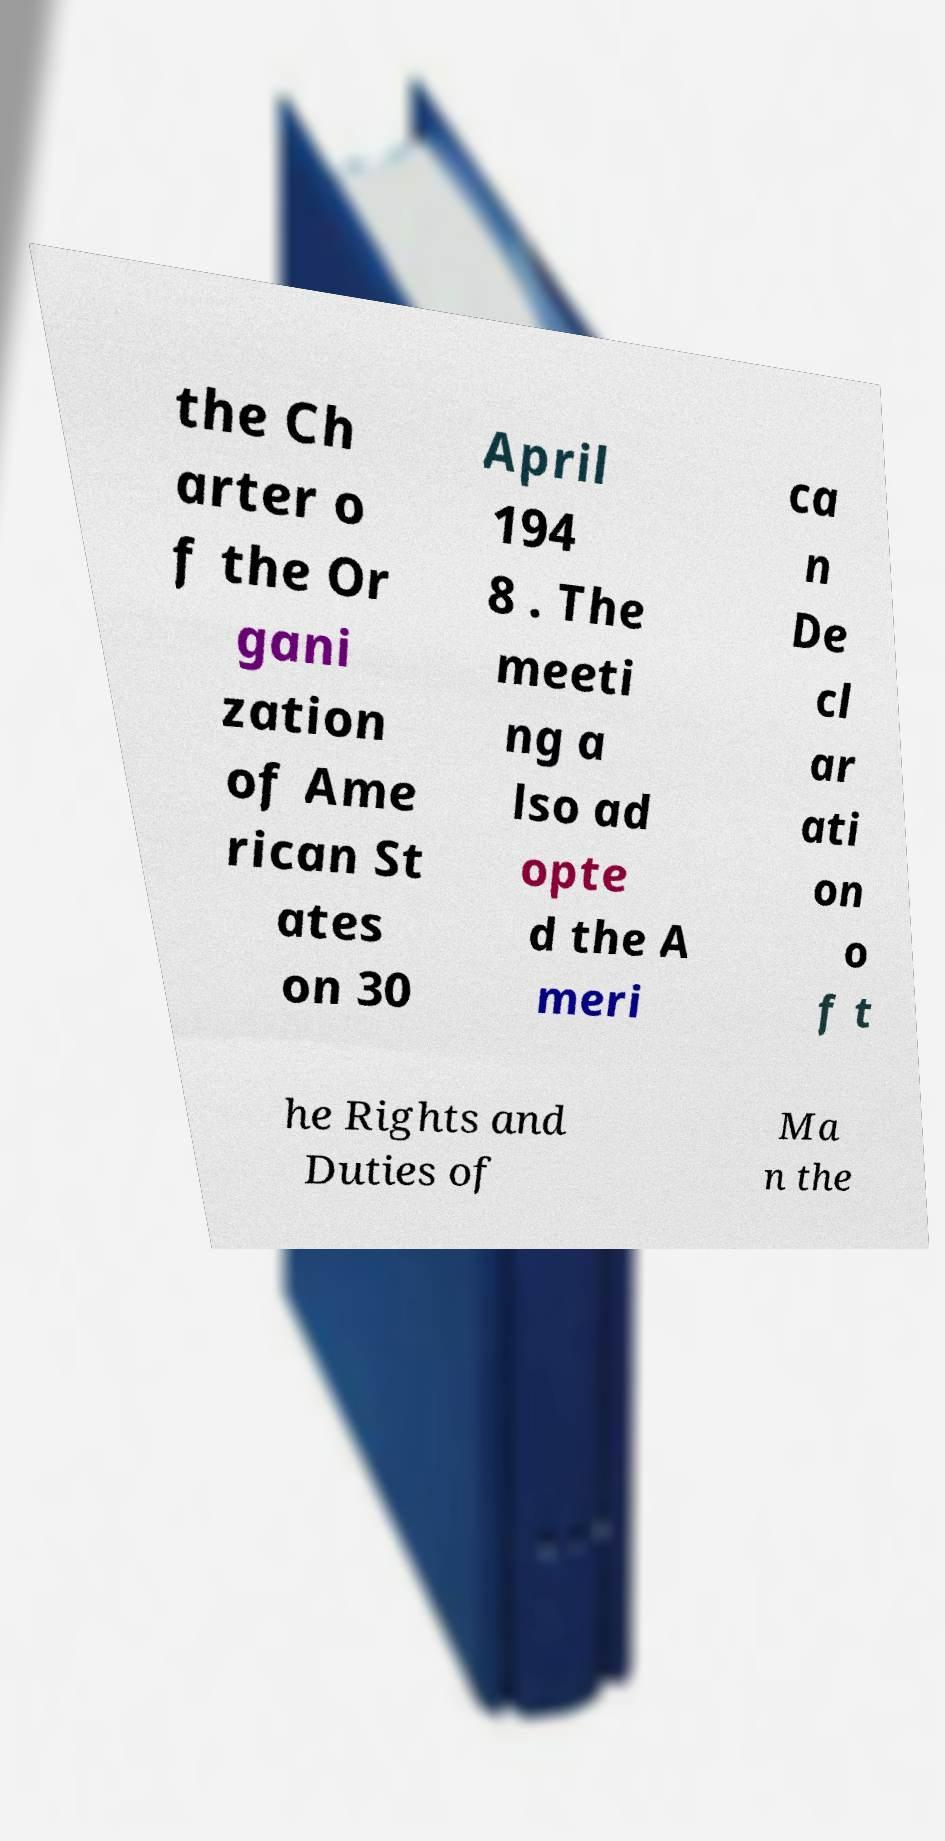For documentation purposes, I need the text within this image transcribed. Could you provide that? the Ch arter o f the Or gani zation of Ame rican St ates on 30 April 194 8 . The meeti ng a lso ad opte d the A meri ca n De cl ar ati on o f t he Rights and Duties of Ma n the 